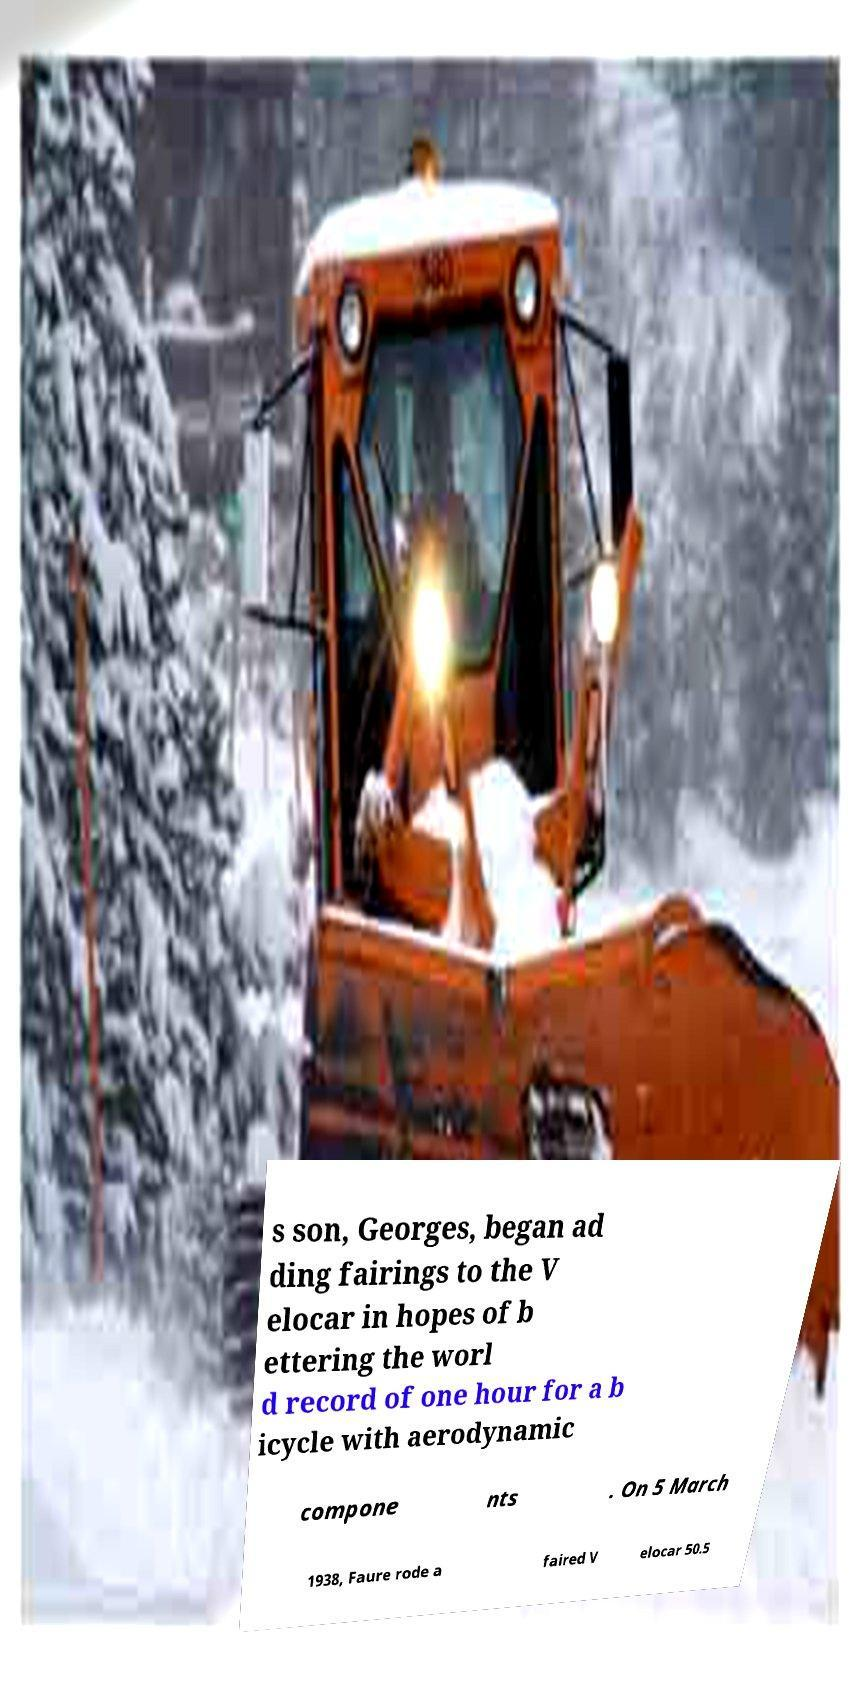Can you accurately transcribe the text from the provided image for me? s son, Georges, began ad ding fairings to the V elocar in hopes of b ettering the worl d record of one hour for a b icycle with aerodynamic compone nts . On 5 March 1938, Faure rode a faired V elocar 50.5 